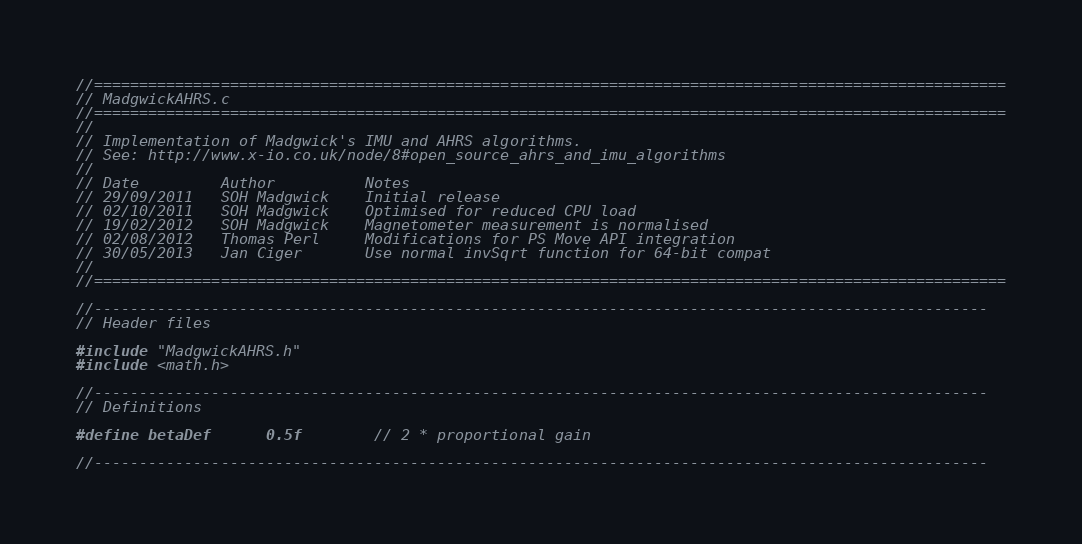<code> <loc_0><loc_0><loc_500><loc_500><_C_>//=====================================================================================================
// MadgwickAHRS.c
//=====================================================================================================
//
// Implementation of Madgwick's IMU and AHRS algorithms.
// See: http://www.x-io.co.uk/node/8#open_source_ahrs_and_imu_algorithms
//
// Date			Author          Notes
// 29/09/2011	SOH Madgwick    Initial release
// 02/10/2011	SOH Madgwick	Optimised for reduced CPU load
// 19/02/2012	SOH Madgwick	Magnetometer measurement is normalised
// 02/08/2012   Thomas Perl     Modifications for PS Move API integration
// 30/05/2013   Jan Ciger       Use normal invSqrt function for 64-bit compat
//
//=====================================================================================================

//---------------------------------------------------------------------------------------------------
// Header files

#include "MadgwickAHRS.h"
#include <math.h>

//---------------------------------------------------------------------------------------------------
// Definitions

#define betaDef		0.5f		// 2 * proportional gain

//---------------------------------------------------------------------------------------------------</code> 